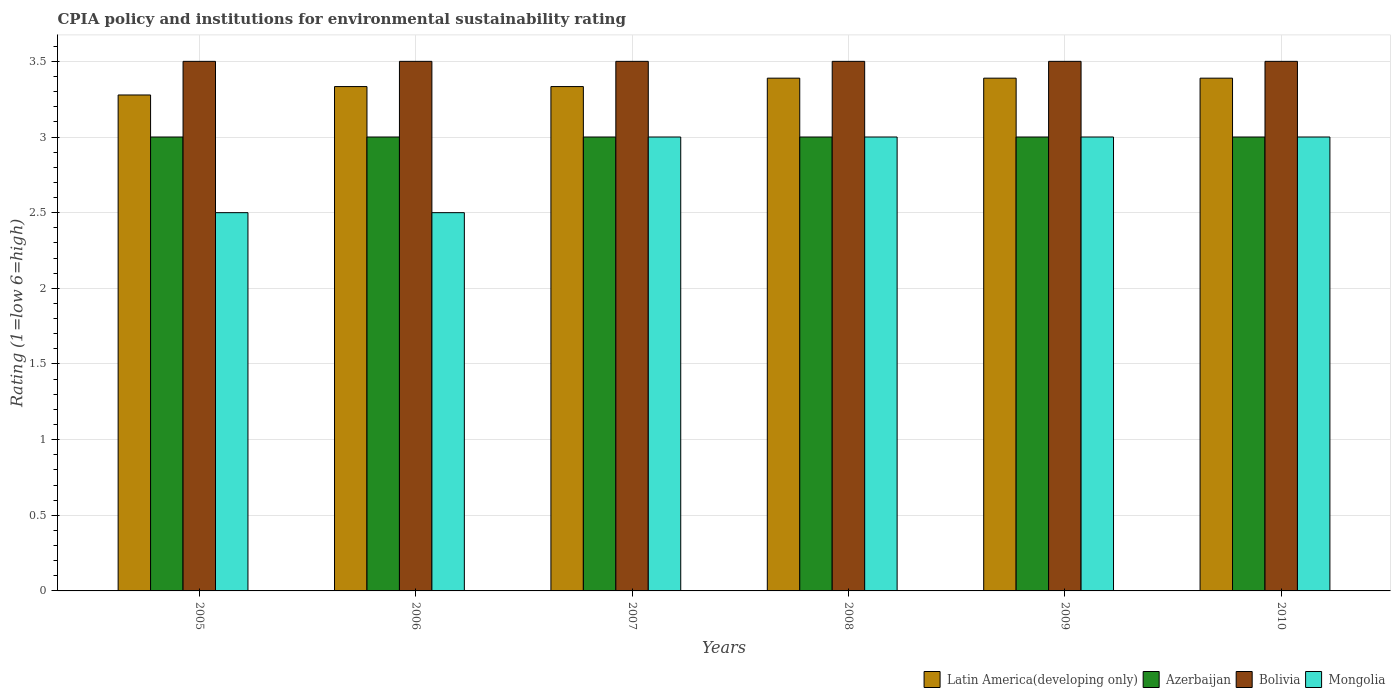How many different coloured bars are there?
Make the answer very short. 4. How many groups of bars are there?
Give a very brief answer. 6. Are the number of bars on each tick of the X-axis equal?
Your answer should be very brief. Yes. How many bars are there on the 6th tick from the left?
Provide a succinct answer. 4. What is the label of the 5th group of bars from the left?
Your response must be concise. 2009. In how many cases, is the number of bars for a given year not equal to the number of legend labels?
Provide a short and direct response. 0. What is the CPIA rating in Latin America(developing only) in 2008?
Your answer should be very brief. 3.39. Across all years, what is the maximum CPIA rating in Latin America(developing only)?
Give a very brief answer. 3.39. Across all years, what is the minimum CPIA rating in Latin America(developing only)?
Keep it short and to the point. 3.28. In which year was the CPIA rating in Latin America(developing only) maximum?
Offer a very short reply. 2008. In which year was the CPIA rating in Azerbaijan minimum?
Provide a short and direct response. 2005. What is the difference between the CPIA rating in Latin America(developing only) in 2006 and that in 2009?
Make the answer very short. -0.06. What is the difference between the CPIA rating in Latin America(developing only) in 2005 and the CPIA rating in Mongolia in 2009?
Ensure brevity in your answer.  0.28. What is the average CPIA rating in Mongolia per year?
Your response must be concise. 2.83. Is the CPIA rating in Mongolia in 2005 less than that in 2008?
Ensure brevity in your answer.  Yes. Is the difference between the CPIA rating in Bolivia in 2007 and 2008 greater than the difference between the CPIA rating in Mongolia in 2007 and 2008?
Provide a succinct answer. No. What is the difference between the highest and the second highest CPIA rating in Bolivia?
Provide a short and direct response. 0. What is the difference between the highest and the lowest CPIA rating in Bolivia?
Your response must be concise. 0. Is it the case that in every year, the sum of the CPIA rating in Mongolia and CPIA rating in Latin America(developing only) is greater than the sum of CPIA rating in Bolivia and CPIA rating in Azerbaijan?
Ensure brevity in your answer.  No. What does the 2nd bar from the left in 2010 represents?
Your answer should be compact. Azerbaijan. What does the 4th bar from the right in 2009 represents?
Provide a short and direct response. Latin America(developing only). What is the difference between two consecutive major ticks on the Y-axis?
Offer a terse response. 0.5. How many legend labels are there?
Provide a succinct answer. 4. How are the legend labels stacked?
Your response must be concise. Horizontal. What is the title of the graph?
Your answer should be very brief. CPIA policy and institutions for environmental sustainability rating. Does "Colombia" appear as one of the legend labels in the graph?
Your answer should be very brief. No. What is the label or title of the X-axis?
Your answer should be compact. Years. What is the label or title of the Y-axis?
Offer a terse response. Rating (1=low 6=high). What is the Rating (1=low 6=high) of Latin America(developing only) in 2005?
Offer a terse response. 3.28. What is the Rating (1=low 6=high) of Bolivia in 2005?
Provide a succinct answer. 3.5. What is the Rating (1=low 6=high) in Mongolia in 2005?
Your answer should be very brief. 2.5. What is the Rating (1=low 6=high) of Latin America(developing only) in 2006?
Provide a short and direct response. 3.33. What is the Rating (1=low 6=high) in Azerbaijan in 2006?
Give a very brief answer. 3. What is the Rating (1=low 6=high) of Mongolia in 2006?
Provide a succinct answer. 2.5. What is the Rating (1=low 6=high) in Latin America(developing only) in 2007?
Your answer should be compact. 3.33. What is the Rating (1=low 6=high) of Bolivia in 2007?
Provide a short and direct response. 3.5. What is the Rating (1=low 6=high) in Mongolia in 2007?
Provide a succinct answer. 3. What is the Rating (1=low 6=high) in Latin America(developing only) in 2008?
Give a very brief answer. 3.39. What is the Rating (1=low 6=high) in Latin America(developing only) in 2009?
Offer a terse response. 3.39. What is the Rating (1=low 6=high) of Mongolia in 2009?
Offer a terse response. 3. What is the Rating (1=low 6=high) of Latin America(developing only) in 2010?
Provide a succinct answer. 3.39. What is the Rating (1=low 6=high) of Bolivia in 2010?
Provide a short and direct response. 3.5. Across all years, what is the maximum Rating (1=low 6=high) in Latin America(developing only)?
Ensure brevity in your answer.  3.39. Across all years, what is the maximum Rating (1=low 6=high) in Mongolia?
Make the answer very short. 3. Across all years, what is the minimum Rating (1=low 6=high) of Latin America(developing only)?
Make the answer very short. 3.28. Across all years, what is the minimum Rating (1=low 6=high) of Azerbaijan?
Provide a short and direct response. 3. Across all years, what is the minimum Rating (1=low 6=high) of Bolivia?
Keep it short and to the point. 3.5. Across all years, what is the minimum Rating (1=low 6=high) of Mongolia?
Your answer should be very brief. 2.5. What is the total Rating (1=low 6=high) in Latin America(developing only) in the graph?
Keep it short and to the point. 20.11. What is the total Rating (1=low 6=high) in Bolivia in the graph?
Your answer should be very brief. 21. What is the total Rating (1=low 6=high) of Mongolia in the graph?
Keep it short and to the point. 17. What is the difference between the Rating (1=low 6=high) of Latin America(developing only) in 2005 and that in 2006?
Offer a very short reply. -0.06. What is the difference between the Rating (1=low 6=high) of Mongolia in 2005 and that in 2006?
Give a very brief answer. 0. What is the difference between the Rating (1=low 6=high) of Latin America(developing only) in 2005 and that in 2007?
Offer a terse response. -0.06. What is the difference between the Rating (1=low 6=high) in Mongolia in 2005 and that in 2007?
Your answer should be very brief. -0.5. What is the difference between the Rating (1=low 6=high) of Latin America(developing only) in 2005 and that in 2008?
Offer a very short reply. -0.11. What is the difference between the Rating (1=low 6=high) in Bolivia in 2005 and that in 2008?
Ensure brevity in your answer.  0. What is the difference between the Rating (1=low 6=high) of Mongolia in 2005 and that in 2008?
Your answer should be very brief. -0.5. What is the difference between the Rating (1=low 6=high) in Latin America(developing only) in 2005 and that in 2009?
Make the answer very short. -0.11. What is the difference between the Rating (1=low 6=high) in Mongolia in 2005 and that in 2009?
Your response must be concise. -0.5. What is the difference between the Rating (1=low 6=high) of Latin America(developing only) in 2005 and that in 2010?
Your answer should be compact. -0.11. What is the difference between the Rating (1=low 6=high) of Azerbaijan in 2005 and that in 2010?
Keep it short and to the point. 0. What is the difference between the Rating (1=low 6=high) in Mongolia in 2005 and that in 2010?
Your answer should be compact. -0.5. What is the difference between the Rating (1=low 6=high) of Bolivia in 2006 and that in 2007?
Offer a very short reply. 0. What is the difference between the Rating (1=low 6=high) in Mongolia in 2006 and that in 2007?
Offer a terse response. -0.5. What is the difference between the Rating (1=low 6=high) of Latin America(developing only) in 2006 and that in 2008?
Offer a very short reply. -0.06. What is the difference between the Rating (1=low 6=high) of Azerbaijan in 2006 and that in 2008?
Keep it short and to the point. 0. What is the difference between the Rating (1=low 6=high) in Bolivia in 2006 and that in 2008?
Give a very brief answer. 0. What is the difference between the Rating (1=low 6=high) in Mongolia in 2006 and that in 2008?
Provide a short and direct response. -0.5. What is the difference between the Rating (1=low 6=high) in Latin America(developing only) in 2006 and that in 2009?
Ensure brevity in your answer.  -0.06. What is the difference between the Rating (1=low 6=high) of Mongolia in 2006 and that in 2009?
Provide a succinct answer. -0.5. What is the difference between the Rating (1=low 6=high) in Latin America(developing only) in 2006 and that in 2010?
Your answer should be compact. -0.06. What is the difference between the Rating (1=low 6=high) in Bolivia in 2006 and that in 2010?
Give a very brief answer. 0. What is the difference between the Rating (1=low 6=high) in Latin America(developing only) in 2007 and that in 2008?
Your answer should be very brief. -0.06. What is the difference between the Rating (1=low 6=high) in Latin America(developing only) in 2007 and that in 2009?
Ensure brevity in your answer.  -0.06. What is the difference between the Rating (1=low 6=high) in Azerbaijan in 2007 and that in 2009?
Keep it short and to the point. 0. What is the difference between the Rating (1=low 6=high) in Bolivia in 2007 and that in 2009?
Offer a very short reply. 0. What is the difference between the Rating (1=low 6=high) of Mongolia in 2007 and that in 2009?
Ensure brevity in your answer.  0. What is the difference between the Rating (1=low 6=high) of Latin America(developing only) in 2007 and that in 2010?
Your answer should be compact. -0.06. What is the difference between the Rating (1=low 6=high) of Azerbaijan in 2007 and that in 2010?
Ensure brevity in your answer.  0. What is the difference between the Rating (1=low 6=high) of Latin America(developing only) in 2008 and that in 2009?
Offer a very short reply. 0. What is the difference between the Rating (1=low 6=high) in Azerbaijan in 2008 and that in 2009?
Offer a very short reply. 0. What is the difference between the Rating (1=low 6=high) in Bolivia in 2008 and that in 2009?
Make the answer very short. 0. What is the difference between the Rating (1=low 6=high) of Mongolia in 2008 and that in 2009?
Provide a succinct answer. 0. What is the difference between the Rating (1=low 6=high) of Latin America(developing only) in 2008 and that in 2010?
Keep it short and to the point. 0. What is the difference between the Rating (1=low 6=high) of Azerbaijan in 2008 and that in 2010?
Your response must be concise. 0. What is the difference between the Rating (1=low 6=high) of Bolivia in 2008 and that in 2010?
Offer a very short reply. 0. What is the difference between the Rating (1=low 6=high) of Bolivia in 2009 and that in 2010?
Your answer should be compact. 0. What is the difference between the Rating (1=low 6=high) of Mongolia in 2009 and that in 2010?
Ensure brevity in your answer.  0. What is the difference between the Rating (1=low 6=high) in Latin America(developing only) in 2005 and the Rating (1=low 6=high) in Azerbaijan in 2006?
Give a very brief answer. 0.28. What is the difference between the Rating (1=low 6=high) of Latin America(developing only) in 2005 and the Rating (1=low 6=high) of Bolivia in 2006?
Give a very brief answer. -0.22. What is the difference between the Rating (1=low 6=high) of Azerbaijan in 2005 and the Rating (1=low 6=high) of Bolivia in 2006?
Make the answer very short. -0.5. What is the difference between the Rating (1=low 6=high) in Azerbaijan in 2005 and the Rating (1=low 6=high) in Mongolia in 2006?
Ensure brevity in your answer.  0.5. What is the difference between the Rating (1=low 6=high) of Bolivia in 2005 and the Rating (1=low 6=high) of Mongolia in 2006?
Your response must be concise. 1. What is the difference between the Rating (1=low 6=high) in Latin America(developing only) in 2005 and the Rating (1=low 6=high) in Azerbaijan in 2007?
Your response must be concise. 0.28. What is the difference between the Rating (1=low 6=high) of Latin America(developing only) in 2005 and the Rating (1=low 6=high) of Bolivia in 2007?
Ensure brevity in your answer.  -0.22. What is the difference between the Rating (1=low 6=high) in Latin America(developing only) in 2005 and the Rating (1=low 6=high) in Mongolia in 2007?
Your answer should be very brief. 0.28. What is the difference between the Rating (1=low 6=high) in Latin America(developing only) in 2005 and the Rating (1=low 6=high) in Azerbaijan in 2008?
Keep it short and to the point. 0.28. What is the difference between the Rating (1=low 6=high) of Latin America(developing only) in 2005 and the Rating (1=low 6=high) of Bolivia in 2008?
Provide a succinct answer. -0.22. What is the difference between the Rating (1=low 6=high) in Latin America(developing only) in 2005 and the Rating (1=low 6=high) in Mongolia in 2008?
Make the answer very short. 0.28. What is the difference between the Rating (1=low 6=high) of Azerbaijan in 2005 and the Rating (1=low 6=high) of Bolivia in 2008?
Your response must be concise. -0.5. What is the difference between the Rating (1=low 6=high) of Azerbaijan in 2005 and the Rating (1=low 6=high) of Mongolia in 2008?
Your answer should be compact. 0. What is the difference between the Rating (1=low 6=high) in Latin America(developing only) in 2005 and the Rating (1=low 6=high) in Azerbaijan in 2009?
Make the answer very short. 0.28. What is the difference between the Rating (1=low 6=high) of Latin America(developing only) in 2005 and the Rating (1=low 6=high) of Bolivia in 2009?
Give a very brief answer. -0.22. What is the difference between the Rating (1=low 6=high) of Latin America(developing only) in 2005 and the Rating (1=low 6=high) of Mongolia in 2009?
Your response must be concise. 0.28. What is the difference between the Rating (1=low 6=high) of Latin America(developing only) in 2005 and the Rating (1=low 6=high) of Azerbaijan in 2010?
Keep it short and to the point. 0.28. What is the difference between the Rating (1=low 6=high) in Latin America(developing only) in 2005 and the Rating (1=low 6=high) in Bolivia in 2010?
Provide a short and direct response. -0.22. What is the difference between the Rating (1=low 6=high) in Latin America(developing only) in 2005 and the Rating (1=low 6=high) in Mongolia in 2010?
Your response must be concise. 0.28. What is the difference between the Rating (1=low 6=high) of Azerbaijan in 2005 and the Rating (1=low 6=high) of Mongolia in 2010?
Make the answer very short. 0. What is the difference between the Rating (1=low 6=high) in Azerbaijan in 2006 and the Rating (1=low 6=high) in Mongolia in 2007?
Make the answer very short. 0. What is the difference between the Rating (1=low 6=high) of Bolivia in 2006 and the Rating (1=low 6=high) of Mongolia in 2007?
Your answer should be compact. 0.5. What is the difference between the Rating (1=low 6=high) in Latin America(developing only) in 2006 and the Rating (1=low 6=high) in Azerbaijan in 2008?
Your answer should be compact. 0.33. What is the difference between the Rating (1=low 6=high) in Latin America(developing only) in 2006 and the Rating (1=low 6=high) in Bolivia in 2008?
Ensure brevity in your answer.  -0.17. What is the difference between the Rating (1=low 6=high) of Latin America(developing only) in 2006 and the Rating (1=low 6=high) of Mongolia in 2008?
Give a very brief answer. 0.33. What is the difference between the Rating (1=low 6=high) in Latin America(developing only) in 2006 and the Rating (1=low 6=high) in Azerbaijan in 2009?
Offer a terse response. 0.33. What is the difference between the Rating (1=low 6=high) in Latin America(developing only) in 2006 and the Rating (1=low 6=high) in Mongolia in 2009?
Make the answer very short. 0.33. What is the difference between the Rating (1=low 6=high) of Azerbaijan in 2006 and the Rating (1=low 6=high) of Mongolia in 2009?
Provide a short and direct response. 0. What is the difference between the Rating (1=low 6=high) in Latin America(developing only) in 2006 and the Rating (1=low 6=high) in Bolivia in 2010?
Offer a terse response. -0.17. What is the difference between the Rating (1=low 6=high) of Latin America(developing only) in 2006 and the Rating (1=low 6=high) of Mongolia in 2010?
Provide a short and direct response. 0.33. What is the difference between the Rating (1=low 6=high) of Azerbaijan in 2006 and the Rating (1=low 6=high) of Mongolia in 2010?
Provide a succinct answer. 0. What is the difference between the Rating (1=low 6=high) in Latin America(developing only) in 2007 and the Rating (1=low 6=high) in Bolivia in 2008?
Keep it short and to the point. -0.17. What is the difference between the Rating (1=low 6=high) of Azerbaijan in 2007 and the Rating (1=low 6=high) of Bolivia in 2008?
Offer a very short reply. -0.5. What is the difference between the Rating (1=low 6=high) in Latin America(developing only) in 2007 and the Rating (1=low 6=high) in Azerbaijan in 2009?
Offer a terse response. 0.33. What is the difference between the Rating (1=low 6=high) of Latin America(developing only) in 2007 and the Rating (1=low 6=high) of Bolivia in 2009?
Ensure brevity in your answer.  -0.17. What is the difference between the Rating (1=low 6=high) in Azerbaijan in 2007 and the Rating (1=low 6=high) in Bolivia in 2009?
Ensure brevity in your answer.  -0.5. What is the difference between the Rating (1=low 6=high) of Latin America(developing only) in 2007 and the Rating (1=low 6=high) of Azerbaijan in 2010?
Ensure brevity in your answer.  0.33. What is the difference between the Rating (1=low 6=high) of Latin America(developing only) in 2007 and the Rating (1=low 6=high) of Mongolia in 2010?
Your answer should be compact. 0.33. What is the difference between the Rating (1=low 6=high) of Latin America(developing only) in 2008 and the Rating (1=low 6=high) of Azerbaijan in 2009?
Keep it short and to the point. 0.39. What is the difference between the Rating (1=low 6=high) of Latin America(developing only) in 2008 and the Rating (1=low 6=high) of Bolivia in 2009?
Your answer should be very brief. -0.11. What is the difference between the Rating (1=low 6=high) of Latin America(developing only) in 2008 and the Rating (1=low 6=high) of Mongolia in 2009?
Offer a terse response. 0.39. What is the difference between the Rating (1=low 6=high) of Azerbaijan in 2008 and the Rating (1=low 6=high) of Mongolia in 2009?
Your answer should be very brief. 0. What is the difference between the Rating (1=low 6=high) of Latin America(developing only) in 2008 and the Rating (1=low 6=high) of Azerbaijan in 2010?
Keep it short and to the point. 0.39. What is the difference between the Rating (1=low 6=high) in Latin America(developing only) in 2008 and the Rating (1=low 6=high) in Bolivia in 2010?
Give a very brief answer. -0.11. What is the difference between the Rating (1=low 6=high) of Latin America(developing only) in 2008 and the Rating (1=low 6=high) of Mongolia in 2010?
Your response must be concise. 0.39. What is the difference between the Rating (1=low 6=high) in Azerbaijan in 2008 and the Rating (1=low 6=high) in Bolivia in 2010?
Provide a succinct answer. -0.5. What is the difference between the Rating (1=low 6=high) of Azerbaijan in 2008 and the Rating (1=low 6=high) of Mongolia in 2010?
Give a very brief answer. 0. What is the difference between the Rating (1=low 6=high) of Latin America(developing only) in 2009 and the Rating (1=low 6=high) of Azerbaijan in 2010?
Keep it short and to the point. 0.39. What is the difference between the Rating (1=low 6=high) of Latin America(developing only) in 2009 and the Rating (1=low 6=high) of Bolivia in 2010?
Keep it short and to the point. -0.11. What is the difference between the Rating (1=low 6=high) of Latin America(developing only) in 2009 and the Rating (1=low 6=high) of Mongolia in 2010?
Keep it short and to the point. 0.39. What is the difference between the Rating (1=low 6=high) in Bolivia in 2009 and the Rating (1=low 6=high) in Mongolia in 2010?
Your answer should be very brief. 0.5. What is the average Rating (1=low 6=high) of Latin America(developing only) per year?
Offer a very short reply. 3.35. What is the average Rating (1=low 6=high) in Bolivia per year?
Provide a succinct answer. 3.5. What is the average Rating (1=low 6=high) of Mongolia per year?
Offer a terse response. 2.83. In the year 2005, what is the difference between the Rating (1=low 6=high) in Latin America(developing only) and Rating (1=low 6=high) in Azerbaijan?
Provide a short and direct response. 0.28. In the year 2005, what is the difference between the Rating (1=low 6=high) in Latin America(developing only) and Rating (1=low 6=high) in Bolivia?
Ensure brevity in your answer.  -0.22. In the year 2006, what is the difference between the Rating (1=low 6=high) in Latin America(developing only) and Rating (1=low 6=high) in Mongolia?
Provide a short and direct response. 0.83. In the year 2007, what is the difference between the Rating (1=low 6=high) of Latin America(developing only) and Rating (1=low 6=high) of Azerbaijan?
Make the answer very short. 0.33. In the year 2007, what is the difference between the Rating (1=low 6=high) of Azerbaijan and Rating (1=low 6=high) of Bolivia?
Your answer should be very brief. -0.5. In the year 2007, what is the difference between the Rating (1=low 6=high) of Azerbaijan and Rating (1=low 6=high) of Mongolia?
Keep it short and to the point. 0. In the year 2008, what is the difference between the Rating (1=low 6=high) of Latin America(developing only) and Rating (1=low 6=high) of Azerbaijan?
Provide a succinct answer. 0.39. In the year 2008, what is the difference between the Rating (1=low 6=high) of Latin America(developing only) and Rating (1=low 6=high) of Bolivia?
Provide a succinct answer. -0.11. In the year 2008, what is the difference between the Rating (1=low 6=high) in Latin America(developing only) and Rating (1=low 6=high) in Mongolia?
Ensure brevity in your answer.  0.39. In the year 2008, what is the difference between the Rating (1=low 6=high) in Azerbaijan and Rating (1=low 6=high) in Bolivia?
Provide a succinct answer. -0.5. In the year 2008, what is the difference between the Rating (1=low 6=high) in Azerbaijan and Rating (1=low 6=high) in Mongolia?
Make the answer very short. 0. In the year 2009, what is the difference between the Rating (1=low 6=high) in Latin America(developing only) and Rating (1=low 6=high) in Azerbaijan?
Give a very brief answer. 0.39. In the year 2009, what is the difference between the Rating (1=low 6=high) of Latin America(developing only) and Rating (1=low 6=high) of Bolivia?
Keep it short and to the point. -0.11. In the year 2009, what is the difference between the Rating (1=low 6=high) in Latin America(developing only) and Rating (1=low 6=high) in Mongolia?
Provide a succinct answer. 0.39. In the year 2009, what is the difference between the Rating (1=low 6=high) in Azerbaijan and Rating (1=low 6=high) in Mongolia?
Your answer should be compact. 0. In the year 2009, what is the difference between the Rating (1=low 6=high) of Bolivia and Rating (1=low 6=high) of Mongolia?
Your answer should be compact. 0.5. In the year 2010, what is the difference between the Rating (1=low 6=high) in Latin America(developing only) and Rating (1=low 6=high) in Azerbaijan?
Offer a very short reply. 0.39. In the year 2010, what is the difference between the Rating (1=low 6=high) of Latin America(developing only) and Rating (1=low 6=high) of Bolivia?
Provide a short and direct response. -0.11. In the year 2010, what is the difference between the Rating (1=low 6=high) of Latin America(developing only) and Rating (1=low 6=high) of Mongolia?
Make the answer very short. 0.39. In the year 2010, what is the difference between the Rating (1=low 6=high) of Azerbaijan and Rating (1=low 6=high) of Bolivia?
Your answer should be very brief. -0.5. In the year 2010, what is the difference between the Rating (1=low 6=high) in Azerbaijan and Rating (1=low 6=high) in Mongolia?
Provide a succinct answer. 0. What is the ratio of the Rating (1=low 6=high) in Latin America(developing only) in 2005 to that in 2006?
Ensure brevity in your answer.  0.98. What is the ratio of the Rating (1=low 6=high) of Bolivia in 2005 to that in 2006?
Your answer should be compact. 1. What is the ratio of the Rating (1=low 6=high) in Mongolia in 2005 to that in 2006?
Provide a short and direct response. 1. What is the ratio of the Rating (1=low 6=high) in Latin America(developing only) in 2005 to that in 2007?
Your response must be concise. 0.98. What is the ratio of the Rating (1=low 6=high) of Bolivia in 2005 to that in 2007?
Keep it short and to the point. 1. What is the ratio of the Rating (1=low 6=high) in Mongolia in 2005 to that in 2007?
Provide a succinct answer. 0.83. What is the ratio of the Rating (1=low 6=high) of Latin America(developing only) in 2005 to that in 2008?
Provide a succinct answer. 0.97. What is the ratio of the Rating (1=low 6=high) of Mongolia in 2005 to that in 2008?
Your response must be concise. 0.83. What is the ratio of the Rating (1=low 6=high) in Latin America(developing only) in 2005 to that in 2009?
Offer a very short reply. 0.97. What is the ratio of the Rating (1=low 6=high) of Azerbaijan in 2005 to that in 2009?
Your response must be concise. 1. What is the ratio of the Rating (1=low 6=high) of Mongolia in 2005 to that in 2009?
Ensure brevity in your answer.  0.83. What is the ratio of the Rating (1=low 6=high) in Latin America(developing only) in 2005 to that in 2010?
Keep it short and to the point. 0.97. What is the ratio of the Rating (1=low 6=high) in Azerbaijan in 2005 to that in 2010?
Provide a short and direct response. 1. What is the ratio of the Rating (1=low 6=high) of Bolivia in 2005 to that in 2010?
Keep it short and to the point. 1. What is the ratio of the Rating (1=low 6=high) of Azerbaijan in 2006 to that in 2007?
Your response must be concise. 1. What is the ratio of the Rating (1=low 6=high) in Bolivia in 2006 to that in 2007?
Provide a succinct answer. 1. What is the ratio of the Rating (1=low 6=high) of Mongolia in 2006 to that in 2007?
Your response must be concise. 0.83. What is the ratio of the Rating (1=low 6=high) in Latin America(developing only) in 2006 to that in 2008?
Give a very brief answer. 0.98. What is the ratio of the Rating (1=low 6=high) in Bolivia in 2006 to that in 2008?
Give a very brief answer. 1. What is the ratio of the Rating (1=low 6=high) in Latin America(developing only) in 2006 to that in 2009?
Give a very brief answer. 0.98. What is the ratio of the Rating (1=low 6=high) of Azerbaijan in 2006 to that in 2009?
Make the answer very short. 1. What is the ratio of the Rating (1=low 6=high) of Bolivia in 2006 to that in 2009?
Your response must be concise. 1. What is the ratio of the Rating (1=low 6=high) of Mongolia in 2006 to that in 2009?
Make the answer very short. 0.83. What is the ratio of the Rating (1=low 6=high) of Latin America(developing only) in 2006 to that in 2010?
Make the answer very short. 0.98. What is the ratio of the Rating (1=low 6=high) in Azerbaijan in 2006 to that in 2010?
Keep it short and to the point. 1. What is the ratio of the Rating (1=low 6=high) in Latin America(developing only) in 2007 to that in 2008?
Give a very brief answer. 0.98. What is the ratio of the Rating (1=low 6=high) of Azerbaijan in 2007 to that in 2008?
Ensure brevity in your answer.  1. What is the ratio of the Rating (1=low 6=high) in Latin America(developing only) in 2007 to that in 2009?
Your answer should be compact. 0.98. What is the ratio of the Rating (1=low 6=high) of Mongolia in 2007 to that in 2009?
Your answer should be very brief. 1. What is the ratio of the Rating (1=low 6=high) in Latin America(developing only) in 2007 to that in 2010?
Provide a succinct answer. 0.98. What is the ratio of the Rating (1=low 6=high) in Bolivia in 2007 to that in 2010?
Your answer should be compact. 1. What is the ratio of the Rating (1=low 6=high) of Azerbaijan in 2008 to that in 2009?
Offer a terse response. 1. What is the ratio of the Rating (1=low 6=high) in Bolivia in 2008 to that in 2009?
Your answer should be compact. 1. What is the ratio of the Rating (1=low 6=high) of Mongolia in 2008 to that in 2009?
Your answer should be compact. 1. What is the ratio of the Rating (1=low 6=high) of Latin America(developing only) in 2008 to that in 2010?
Your response must be concise. 1. What is the ratio of the Rating (1=low 6=high) in Azerbaijan in 2009 to that in 2010?
Give a very brief answer. 1. What is the ratio of the Rating (1=low 6=high) of Mongolia in 2009 to that in 2010?
Your answer should be compact. 1. What is the difference between the highest and the second highest Rating (1=low 6=high) of Latin America(developing only)?
Keep it short and to the point. 0. What is the difference between the highest and the second highest Rating (1=low 6=high) of Bolivia?
Your response must be concise. 0. What is the difference between the highest and the lowest Rating (1=low 6=high) of Azerbaijan?
Keep it short and to the point. 0. What is the difference between the highest and the lowest Rating (1=low 6=high) of Mongolia?
Provide a short and direct response. 0.5. 